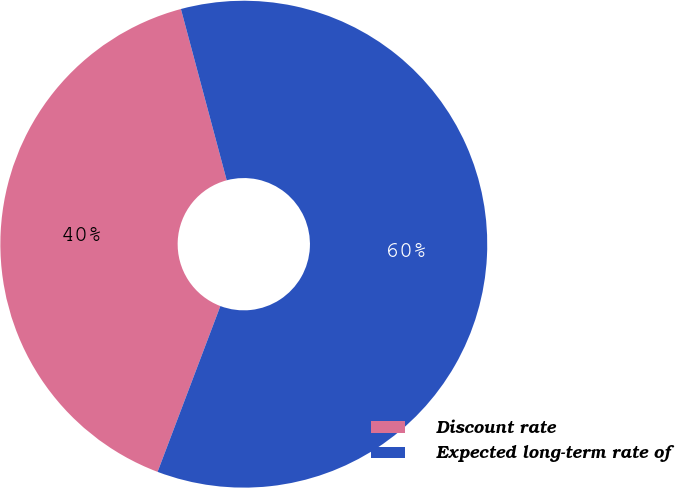<chart> <loc_0><loc_0><loc_500><loc_500><pie_chart><fcel>Discount rate<fcel>Expected long-term rate of<nl><fcel>40.08%<fcel>59.92%<nl></chart> 